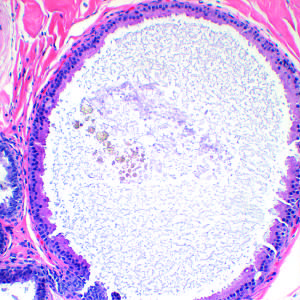what is an apocrine cyst?
Answer the question using a single word or phrase. A common feature of nonproliferative breast disease 